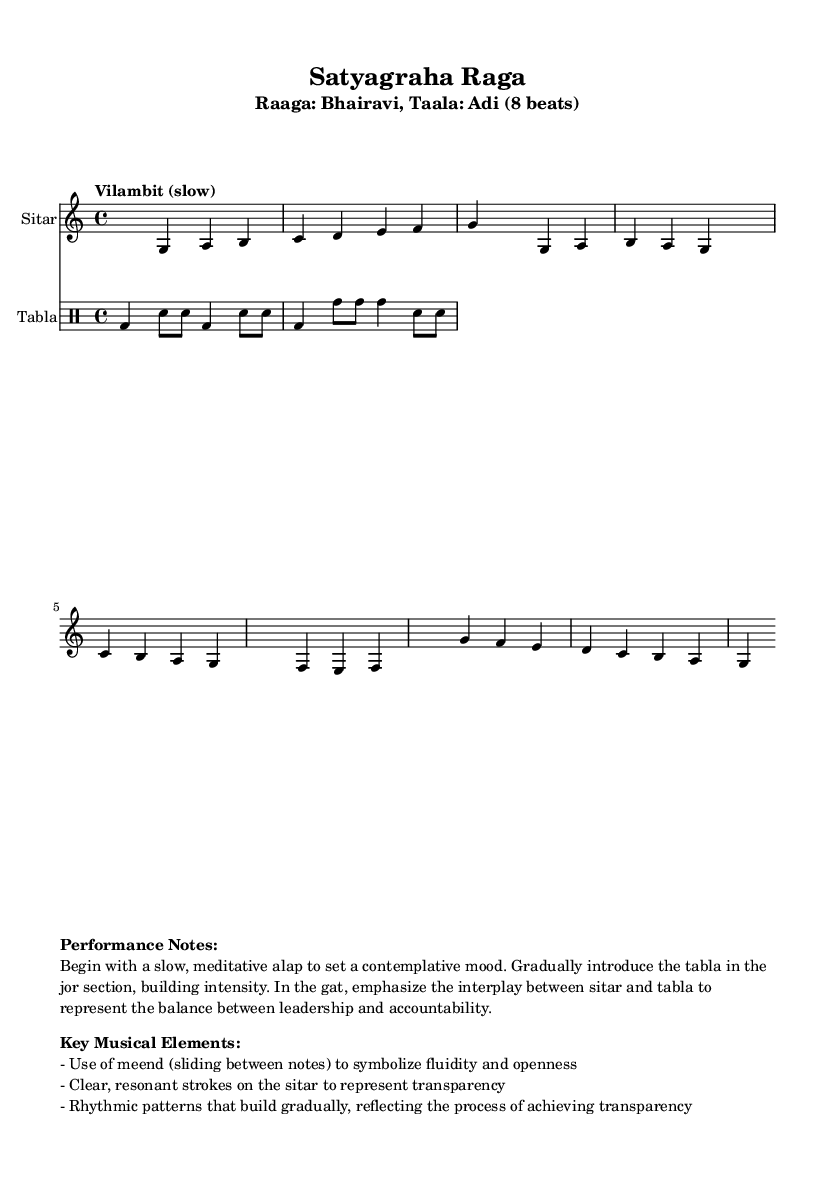What is the time signature of this music? The time signature is indicated at the beginning of the score. It is shown as 4/4, which means there are four beats in each measure.
Answer: 4/4 What is the key signature of this music? The key signature is noted at the start of the music as C major. C major has no sharps or flats, which is typical in many pieces.
Answer: C major What is the tempo marking for this composition? The tempo marking is present right after the time signature. It reads "Vilambit (slow)," indicating a slow tempo for the piece.
Answer: Vilambit (slow) How many beats are in each measure? The beats per measure can be deduced from the time signature, which is 4/4, indicating 4 beats per measure.
Answer: 4 In which section does the tabla begin to be introduced? The introduction of the tabla can be inferred from the provided performance notes, specifically mentioning the jor section as when the tabla starts playing.
Answer: Jor What does the use of meend symbolize in this piece? The performance notes describe the use of meend as symbolizing fluidity and openness, associated with the theme of transparency in governance.
Answer: Fluidity and openness What musical elements are emphasized in the gat section? The performance notes mention emphasis on the interplay between the sitar and tabla in the gat section, which represents the balance between leadership and accountability.
Answer: Balance between leadership and accountability 